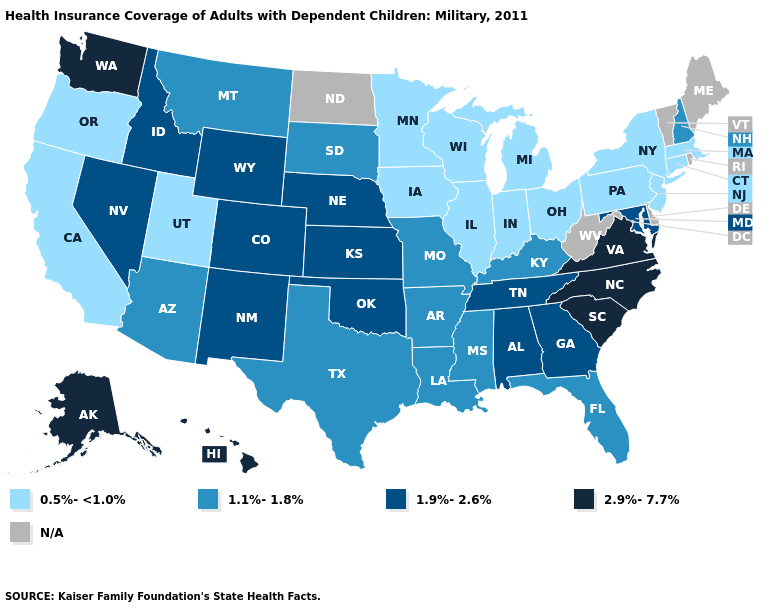What is the value of Arkansas?
Keep it brief. 1.1%-1.8%. What is the value of South Carolina?
Be succinct. 2.9%-7.7%. What is the lowest value in the USA?
Answer briefly. 0.5%-<1.0%. What is the lowest value in the USA?
Answer briefly. 0.5%-<1.0%. What is the lowest value in the West?
Be succinct. 0.5%-<1.0%. Among the states that border Montana , which have the lowest value?
Answer briefly. South Dakota. Name the states that have a value in the range 1.9%-2.6%?
Concise answer only. Alabama, Colorado, Georgia, Idaho, Kansas, Maryland, Nebraska, Nevada, New Mexico, Oklahoma, Tennessee, Wyoming. Which states have the highest value in the USA?
Keep it brief. Alaska, Hawaii, North Carolina, South Carolina, Virginia, Washington. What is the highest value in states that border New Mexico?
Answer briefly. 1.9%-2.6%. What is the value of South Dakota?
Short answer required. 1.1%-1.8%. Among the states that border Washington , does Idaho have the highest value?
Keep it brief. Yes. Name the states that have a value in the range 2.9%-7.7%?
Be succinct. Alaska, Hawaii, North Carolina, South Carolina, Virginia, Washington. 